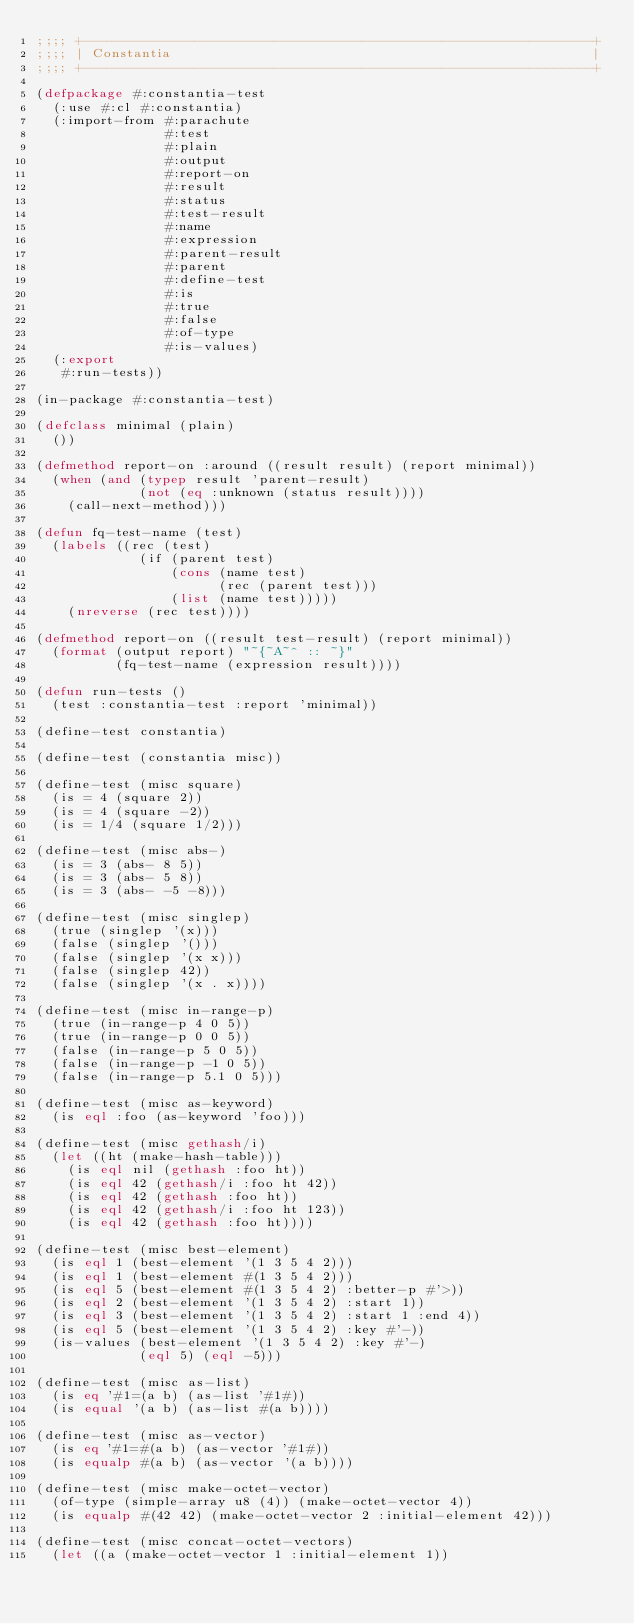Convert code to text. <code><loc_0><loc_0><loc_500><loc_500><_Lisp_>;;;; +----------------------------------------------------------------+
;;;; | Constantia                                                     |
;;;; +----------------------------------------------------------------+

(defpackage #:constantia-test
  (:use #:cl #:constantia)
  (:import-from #:parachute
                #:test
                #:plain
                #:output
                #:report-on
                #:result
                #:status
                #:test-result
                #:name
                #:expression
                #:parent-result
                #:parent
                #:define-test
                #:is
                #:true
                #:false
                #:of-type
                #:is-values)
  (:export
   #:run-tests))

(in-package #:constantia-test)

(defclass minimal (plain)
  ())

(defmethod report-on :around ((result result) (report minimal))
  (when (and (typep result 'parent-result)
             (not (eq :unknown (status result))))
    (call-next-method)))

(defun fq-test-name (test)
  (labels ((rec (test)
             (if (parent test)
                 (cons (name test)
                       (rec (parent test)))
                 (list (name test)))))
    (nreverse (rec test))))

(defmethod report-on ((result test-result) (report minimal))
  (format (output report) "~{~A~^ :: ~}"
          (fq-test-name (expression result))))

(defun run-tests ()
  (test :constantia-test :report 'minimal))

(define-test constantia)

(define-test (constantia misc))

(define-test (misc square)
  (is = 4 (square 2))
  (is = 4 (square -2))
  (is = 1/4 (square 1/2)))

(define-test (misc abs-)
  (is = 3 (abs- 8 5))
  (is = 3 (abs- 5 8))
  (is = 3 (abs- -5 -8)))

(define-test (misc singlep)
  (true (singlep '(x)))
  (false (singlep '()))
  (false (singlep '(x x)))
  (false (singlep 42))
  (false (singlep '(x . x))))

(define-test (misc in-range-p)
  (true (in-range-p 4 0 5))
  (true (in-range-p 0 0 5))
  (false (in-range-p 5 0 5))
  (false (in-range-p -1 0 5))
  (false (in-range-p 5.1 0 5)))

(define-test (misc as-keyword)
  (is eql :foo (as-keyword 'foo)))

(define-test (misc gethash/i)
  (let ((ht (make-hash-table)))
    (is eql nil (gethash :foo ht))
    (is eql 42 (gethash/i :foo ht 42))
    (is eql 42 (gethash :foo ht))
    (is eql 42 (gethash/i :foo ht 123))
    (is eql 42 (gethash :foo ht))))

(define-test (misc best-element)
  (is eql 1 (best-element '(1 3 5 4 2)))
  (is eql 1 (best-element #(1 3 5 4 2)))
  (is eql 5 (best-element #(1 3 5 4 2) :better-p #'>))
  (is eql 2 (best-element '(1 3 5 4 2) :start 1))
  (is eql 3 (best-element '(1 3 5 4 2) :start 1 :end 4))
  (is eql 5 (best-element '(1 3 5 4 2) :key #'-))
  (is-values (best-element '(1 3 5 4 2) :key #'-)
             (eql 5) (eql -5)))

(define-test (misc as-list)
  (is eq '#1=(a b) (as-list '#1#))
  (is equal '(a b) (as-list #(a b))))

(define-test (misc as-vector)
  (is eq '#1=#(a b) (as-vector '#1#))
  (is equalp #(a b) (as-vector '(a b))))

(define-test (misc make-octet-vector)
  (of-type (simple-array u8 (4)) (make-octet-vector 4))
  (is equalp #(42 42) (make-octet-vector 2 :initial-element 42)))

(define-test (misc concat-octet-vectors)
  (let ((a (make-octet-vector 1 :initial-element 1))</code> 